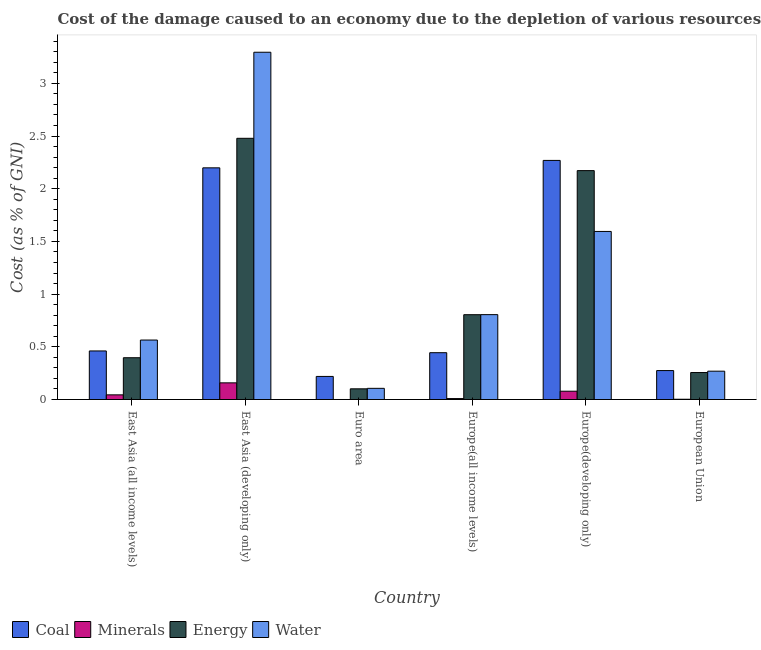How many groups of bars are there?
Offer a very short reply. 6. Are the number of bars per tick equal to the number of legend labels?
Give a very brief answer. Yes. How many bars are there on the 4th tick from the left?
Your answer should be very brief. 4. How many bars are there on the 1st tick from the right?
Give a very brief answer. 4. What is the label of the 1st group of bars from the left?
Give a very brief answer. East Asia (all income levels). In how many cases, is the number of bars for a given country not equal to the number of legend labels?
Provide a succinct answer. 0. What is the cost of damage due to depletion of energy in East Asia (all income levels)?
Keep it short and to the point. 0.4. Across all countries, what is the maximum cost of damage due to depletion of water?
Ensure brevity in your answer.  3.3. Across all countries, what is the minimum cost of damage due to depletion of minerals?
Offer a terse response. 0. In which country was the cost of damage due to depletion of energy maximum?
Your answer should be very brief. East Asia (developing only). What is the total cost of damage due to depletion of water in the graph?
Give a very brief answer. 6.63. What is the difference between the cost of damage due to depletion of water in East Asia (all income levels) and that in European Union?
Provide a short and direct response. 0.3. What is the difference between the cost of damage due to depletion of coal in Euro area and the cost of damage due to depletion of water in European Union?
Your response must be concise. -0.05. What is the average cost of damage due to depletion of energy per country?
Give a very brief answer. 1.03. What is the difference between the cost of damage due to depletion of minerals and cost of damage due to depletion of coal in Euro area?
Keep it short and to the point. -0.22. In how many countries, is the cost of damage due to depletion of energy greater than 2.8 %?
Provide a short and direct response. 0. What is the ratio of the cost of damage due to depletion of coal in East Asia (all income levels) to that in Euro area?
Provide a succinct answer. 2.1. Is the cost of damage due to depletion of water in Europe(all income levels) less than that in Europe(developing only)?
Ensure brevity in your answer.  Yes. Is the difference between the cost of damage due to depletion of water in Europe(all income levels) and Europe(developing only) greater than the difference between the cost of damage due to depletion of minerals in Europe(all income levels) and Europe(developing only)?
Ensure brevity in your answer.  No. What is the difference between the highest and the second highest cost of damage due to depletion of water?
Give a very brief answer. 1.7. What is the difference between the highest and the lowest cost of damage due to depletion of coal?
Make the answer very short. 2.05. Is the sum of the cost of damage due to depletion of minerals in Europe(all income levels) and Europe(developing only) greater than the maximum cost of damage due to depletion of energy across all countries?
Your answer should be compact. No. Is it the case that in every country, the sum of the cost of damage due to depletion of energy and cost of damage due to depletion of coal is greater than the sum of cost of damage due to depletion of minerals and cost of damage due to depletion of water?
Provide a succinct answer. Yes. What does the 1st bar from the left in East Asia (all income levels) represents?
Your answer should be compact. Coal. What does the 2nd bar from the right in East Asia (all income levels) represents?
Provide a succinct answer. Energy. Is it the case that in every country, the sum of the cost of damage due to depletion of coal and cost of damage due to depletion of minerals is greater than the cost of damage due to depletion of energy?
Your answer should be compact. No. Are all the bars in the graph horizontal?
Your response must be concise. No. How many countries are there in the graph?
Ensure brevity in your answer.  6. Does the graph contain any zero values?
Provide a short and direct response. No. Where does the legend appear in the graph?
Your answer should be very brief. Bottom left. What is the title of the graph?
Ensure brevity in your answer.  Cost of the damage caused to an economy due to the depletion of various resources in 1993 . What is the label or title of the X-axis?
Make the answer very short. Country. What is the label or title of the Y-axis?
Provide a succinct answer. Cost (as % of GNI). What is the Cost (as % of GNI) in Coal in East Asia (all income levels)?
Make the answer very short. 0.46. What is the Cost (as % of GNI) of Minerals in East Asia (all income levels)?
Offer a terse response. 0.04. What is the Cost (as % of GNI) in Energy in East Asia (all income levels)?
Your answer should be compact. 0.4. What is the Cost (as % of GNI) in Water in East Asia (all income levels)?
Make the answer very short. 0.56. What is the Cost (as % of GNI) of Coal in East Asia (developing only)?
Your answer should be compact. 2.2. What is the Cost (as % of GNI) in Minerals in East Asia (developing only)?
Make the answer very short. 0.16. What is the Cost (as % of GNI) in Energy in East Asia (developing only)?
Provide a succinct answer. 2.48. What is the Cost (as % of GNI) in Water in East Asia (developing only)?
Your answer should be very brief. 3.3. What is the Cost (as % of GNI) in Coal in Euro area?
Your response must be concise. 0.22. What is the Cost (as % of GNI) in Minerals in Euro area?
Provide a short and direct response. 0. What is the Cost (as % of GNI) of Energy in Euro area?
Provide a short and direct response. 0.1. What is the Cost (as % of GNI) of Water in Euro area?
Your answer should be very brief. 0.11. What is the Cost (as % of GNI) in Coal in Europe(all income levels)?
Your answer should be compact. 0.44. What is the Cost (as % of GNI) of Minerals in Europe(all income levels)?
Provide a succinct answer. 0.01. What is the Cost (as % of GNI) in Energy in Europe(all income levels)?
Your answer should be compact. 0.8. What is the Cost (as % of GNI) of Water in Europe(all income levels)?
Provide a short and direct response. 0.81. What is the Cost (as % of GNI) in Coal in Europe(developing only)?
Provide a succinct answer. 2.27. What is the Cost (as % of GNI) in Minerals in Europe(developing only)?
Ensure brevity in your answer.  0.08. What is the Cost (as % of GNI) of Energy in Europe(developing only)?
Make the answer very short. 2.17. What is the Cost (as % of GNI) in Water in Europe(developing only)?
Ensure brevity in your answer.  1.59. What is the Cost (as % of GNI) of Coal in European Union?
Ensure brevity in your answer.  0.27. What is the Cost (as % of GNI) of Minerals in European Union?
Keep it short and to the point. 0. What is the Cost (as % of GNI) of Energy in European Union?
Give a very brief answer. 0.26. What is the Cost (as % of GNI) in Water in European Union?
Ensure brevity in your answer.  0.27. Across all countries, what is the maximum Cost (as % of GNI) of Coal?
Ensure brevity in your answer.  2.27. Across all countries, what is the maximum Cost (as % of GNI) in Minerals?
Keep it short and to the point. 0.16. Across all countries, what is the maximum Cost (as % of GNI) of Energy?
Keep it short and to the point. 2.48. Across all countries, what is the maximum Cost (as % of GNI) of Water?
Offer a terse response. 3.3. Across all countries, what is the minimum Cost (as % of GNI) of Coal?
Provide a short and direct response. 0.22. Across all countries, what is the minimum Cost (as % of GNI) of Minerals?
Give a very brief answer. 0. Across all countries, what is the minimum Cost (as % of GNI) of Energy?
Offer a very short reply. 0.1. Across all countries, what is the minimum Cost (as % of GNI) of Water?
Provide a short and direct response. 0.11. What is the total Cost (as % of GNI) of Coal in the graph?
Give a very brief answer. 5.87. What is the total Cost (as % of GNI) of Minerals in the graph?
Provide a short and direct response. 0.29. What is the total Cost (as % of GNI) of Energy in the graph?
Your answer should be very brief. 6.21. What is the total Cost (as % of GNI) in Water in the graph?
Keep it short and to the point. 6.63. What is the difference between the Cost (as % of GNI) in Coal in East Asia (all income levels) and that in East Asia (developing only)?
Offer a terse response. -1.74. What is the difference between the Cost (as % of GNI) in Minerals in East Asia (all income levels) and that in East Asia (developing only)?
Your answer should be very brief. -0.11. What is the difference between the Cost (as % of GNI) of Energy in East Asia (all income levels) and that in East Asia (developing only)?
Make the answer very short. -2.08. What is the difference between the Cost (as % of GNI) of Water in East Asia (all income levels) and that in East Asia (developing only)?
Your answer should be compact. -2.73. What is the difference between the Cost (as % of GNI) of Coal in East Asia (all income levels) and that in Euro area?
Keep it short and to the point. 0.24. What is the difference between the Cost (as % of GNI) of Minerals in East Asia (all income levels) and that in Euro area?
Offer a very short reply. 0.04. What is the difference between the Cost (as % of GNI) of Energy in East Asia (all income levels) and that in Euro area?
Your answer should be very brief. 0.29. What is the difference between the Cost (as % of GNI) of Water in East Asia (all income levels) and that in Euro area?
Your answer should be compact. 0.46. What is the difference between the Cost (as % of GNI) of Coal in East Asia (all income levels) and that in Europe(all income levels)?
Your response must be concise. 0.02. What is the difference between the Cost (as % of GNI) of Minerals in East Asia (all income levels) and that in Europe(all income levels)?
Ensure brevity in your answer.  0.04. What is the difference between the Cost (as % of GNI) of Energy in East Asia (all income levels) and that in Europe(all income levels)?
Offer a very short reply. -0.41. What is the difference between the Cost (as % of GNI) in Water in East Asia (all income levels) and that in Europe(all income levels)?
Offer a very short reply. -0.24. What is the difference between the Cost (as % of GNI) of Coal in East Asia (all income levels) and that in Europe(developing only)?
Give a very brief answer. -1.81. What is the difference between the Cost (as % of GNI) in Minerals in East Asia (all income levels) and that in Europe(developing only)?
Keep it short and to the point. -0.03. What is the difference between the Cost (as % of GNI) of Energy in East Asia (all income levels) and that in Europe(developing only)?
Provide a short and direct response. -1.78. What is the difference between the Cost (as % of GNI) of Water in East Asia (all income levels) and that in Europe(developing only)?
Ensure brevity in your answer.  -1.03. What is the difference between the Cost (as % of GNI) of Coal in East Asia (all income levels) and that in European Union?
Make the answer very short. 0.19. What is the difference between the Cost (as % of GNI) of Minerals in East Asia (all income levels) and that in European Union?
Offer a terse response. 0.04. What is the difference between the Cost (as % of GNI) in Energy in East Asia (all income levels) and that in European Union?
Provide a short and direct response. 0.14. What is the difference between the Cost (as % of GNI) of Water in East Asia (all income levels) and that in European Union?
Offer a very short reply. 0.3. What is the difference between the Cost (as % of GNI) in Coal in East Asia (developing only) and that in Euro area?
Your answer should be very brief. 1.98. What is the difference between the Cost (as % of GNI) in Minerals in East Asia (developing only) and that in Euro area?
Offer a terse response. 0.16. What is the difference between the Cost (as % of GNI) of Energy in East Asia (developing only) and that in Euro area?
Your answer should be compact. 2.38. What is the difference between the Cost (as % of GNI) of Water in East Asia (developing only) and that in Euro area?
Your answer should be very brief. 3.19. What is the difference between the Cost (as % of GNI) in Coal in East Asia (developing only) and that in Europe(all income levels)?
Offer a very short reply. 1.75. What is the difference between the Cost (as % of GNI) of Minerals in East Asia (developing only) and that in Europe(all income levels)?
Ensure brevity in your answer.  0.15. What is the difference between the Cost (as % of GNI) in Energy in East Asia (developing only) and that in Europe(all income levels)?
Give a very brief answer. 1.67. What is the difference between the Cost (as % of GNI) in Water in East Asia (developing only) and that in Europe(all income levels)?
Offer a very short reply. 2.49. What is the difference between the Cost (as % of GNI) of Coal in East Asia (developing only) and that in Europe(developing only)?
Make the answer very short. -0.07. What is the difference between the Cost (as % of GNI) of Minerals in East Asia (developing only) and that in Europe(developing only)?
Provide a succinct answer. 0.08. What is the difference between the Cost (as % of GNI) in Energy in East Asia (developing only) and that in Europe(developing only)?
Your response must be concise. 0.31. What is the difference between the Cost (as % of GNI) of Water in East Asia (developing only) and that in Europe(developing only)?
Your answer should be very brief. 1.7. What is the difference between the Cost (as % of GNI) in Coal in East Asia (developing only) and that in European Union?
Make the answer very short. 1.92. What is the difference between the Cost (as % of GNI) in Minerals in East Asia (developing only) and that in European Union?
Make the answer very short. 0.16. What is the difference between the Cost (as % of GNI) of Energy in East Asia (developing only) and that in European Union?
Keep it short and to the point. 2.22. What is the difference between the Cost (as % of GNI) in Water in East Asia (developing only) and that in European Union?
Ensure brevity in your answer.  3.03. What is the difference between the Cost (as % of GNI) in Coal in Euro area and that in Europe(all income levels)?
Make the answer very short. -0.23. What is the difference between the Cost (as % of GNI) in Minerals in Euro area and that in Europe(all income levels)?
Your answer should be compact. -0.01. What is the difference between the Cost (as % of GNI) in Energy in Euro area and that in Europe(all income levels)?
Provide a succinct answer. -0.7. What is the difference between the Cost (as % of GNI) in Water in Euro area and that in Europe(all income levels)?
Your answer should be very brief. -0.7. What is the difference between the Cost (as % of GNI) in Coal in Euro area and that in Europe(developing only)?
Keep it short and to the point. -2.05. What is the difference between the Cost (as % of GNI) in Minerals in Euro area and that in Europe(developing only)?
Your response must be concise. -0.08. What is the difference between the Cost (as % of GNI) in Energy in Euro area and that in Europe(developing only)?
Offer a very short reply. -2.07. What is the difference between the Cost (as % of GNI) in Water in Euro area and that in Europe(developing only)?
Make the answer very short. -1.49. What is the difference between the Cost (as % of GNI) of Coal in Euro area and that in European Union?
Make the answer very short. -0.06. What is the difference between the Cost (as % of GNI) in Minerals in Euro area and that in European Union?
Keep it short and to the point. -0. What is the difference between the Cost (as % of GNI) in Energy in Euro area and that in European Union?
Offer a very short reply. -0.15. What is the difference between the Cost (as % of GNI) in Water in Euro area and that in European Union?
Offer a very short reply. -0.16. What is the difference between the Cost (as % of GNI) in Coal in Europe(all income levels) and that in Europe(developing only)?
Provide a succinct answer. -1.82. What is the difference between the Cost (as % of GNI) in Minerals in Europe(all income levels) and that in Europe(developing only)?
Your response must be concise. -0.07. What is the difference between the Cost (as % of GNI) of Energy in Europe(all income levels) and that in Europe(developing only)?
Your answer should be compact. -1.37. What is the difference between the Cost (as % of GNI) in Water in Europe(all income levels) and that in Europe(developing only)?
Provide a short and direct response. -0.79. What is the difference between the Cost (as % of GNI) of Coal in Europe(all income levels) and that in European Union?
Your answer should be very brief. 0.17. What is the difference between the Cost (as % of GNI) in Minerals in Europe(all income levels) and that in European Union?
Ensure brevity in your answer.  0.01. What is the difference between the Cost (as % of GNI) of Energy in Europe(all income levels) and that in European Union?
Ensure brevity in your answer.  0.55. What is the difference between the Cost (as % of GNI) of Water in Europe(all income levels) and that in European Union?
Provide a short and direct response. 0.54. What is the difference between the Cost (as % of GNI) of Coal in Europe(developing only) and that in European Union?
Your answer should be very brief. 1.99. What is the difference between the Cost (as % of GNI) of Minerals in Europe(developing only) and that in European Union?
Your response must be concise. 0.08. What is the difference between the Cost (as % of GNI) in Energy in Europe(developing only) and that in European Union?
Provide a succinct answer. 1.92. What is the difference between the Cost (as % of GNI) of Water in Europe(developing only) and that in European Union?
Provide a succinct answer. 1.33. What is the difference between the Cost (as % of GNI) of Coal in East Asia (all income levels) and the Cost (as % of GNI) of Minerals in East Asia (developing only)?
Give a very brief answer. 0.3. What is the difference between the Cost (as % of GNI) of Coal in East Asia (all income levels) and the Cost (as % of GNI) of Energy in East Asia (developing only)?
Offer a terse response. -2.02. What is the difference between the Cost (as % of GNI) in Coal in East Asia (all income levels) and the Cost (as % of GNI) in Water in East Asia (developing only)?
Your answer should be compact. -2.83. What is the difference between the Cost (as % of GNI) in Minerals in East Asia (all income levels) and the Cost (as % of GNI) in Energy in East Asia (developing only)?
Keep it short and to the point. -2.43. What is the difference between the Cost (as % of GNI) of Minerals in East Asia (all income levels) and the Cost (as % of GNI) of Water in East Asia (developing only)?
Make the answer very short. -3.25. What is the difference between the Cost (as % of GNI) in Energy in East Asia (all income levels) and the Cost (as % of GNI) in Water in East Asia (developing only)?
Your response must be concise. -2.9. What is the difference between the Cost (as % of GNI) of Coal in East Asia (all income levels) and the Cost (as % of GNI) of Minerals in Euro area?
Provide a short and direct response. 0.46. What is the difference between the Cost (as % of GNI) in Coal in East Asia (all income levels) and the Cost (as % of GNI) in Energy in Euro area?
Offer a very short reply. 0.36. What is the difference between the Cost (as % of GNI) in Coal in East Asia (all income levels) and the Cost (as % of GNI) in Water in Euro area?
Offer a terse response. 0.35. What is the difference between the Cost (as % of GNI) in Minerals in East Asia (all income levels) and the Cost (as % of GNI) in Energy in Euro area?
Keep it short and to the point. -0.06. What is the difference between the Cost (as % of GNI) of Minerals in East Asia (all income levels) and the Cost (as % of GNI) of Water in Euro area?
Your answer should be very brief. -0.06. What is the difference between the Cost (as % of GNI) of Energy in East Asia (all income levels) and the Cost (as % of GNI) of Water in Euro area?
Give a very brief answer. 0.29. What is the difference between the Cost (as % of GNI) of Coal in East Asia (all income levels) and the Cost (as % of GNI) of Minerals in Europe(all income levels)?
Keep it short and to the point. 0.45. What is the difference between the Cost (as % of GNI) in Coal in East Asia (all income levels) and the Cost (as % of GNI) in Energy in Europe(all income levels)?
Keep it short and to the point. -0.34. What is the difference between the Cost (as % of GNI) of Coal in East Asia (all income levels) and the Cost (as % of GNI) of Water in Europe(all income levels)?
Your answer should be very brief. -0.34. What is the difference between the Cost (as % of GNI) in Minerals in East Asia (all income levels) and the Cost (as % of GNI) in Energy in Europe(all income levels)?
Provide a succinct answer. -0.76. What is the difference between the Cost (as % of GNI) in Minerals in East Asia (all income levels) and the Cost (as % of GNI) in Water in Europe(all income levels)?
Give a very brief answer. -0.76. What is the difference between the Cost (as % of GNI) in Energy in East Asia (all income levels) and the Cost (as % of GNI) in Water in Europe(all income levels)?
Ensure brevity in your answer.  -0.41. What is the difference between the Cost (as % of GNI) of Coal in East Asia (all income levels) and the Cost (as % of GNI) of Minerals in Europe(developing only)?
Provide a succinct answer. 0.38. What is the difference between the Cost (as % of GNI) of Coal in East Asia (all income levels) and the Cost (as % of GNI) of Energy in Europe(developing only)?
Your answer should be compact. -1.71. What is the difference between the Cost (as % of GNI) in Coal in East Asia (all income levels) and the Cost (as % of GNI) in Water in Europe(developing only)?
Make the answer very short. -1.13. What is the difference between the Cost (as % of GNI) of Minerals in East Asia (all income levels) and the Cost (as % of GNI) of Energy in Europe(developing only)?
Offer a very short reply. -2.13. What is the difference between the Cost (as % of GNI) of Minerals in East Asia (all income levels) and the Cost (as % of GNI) of Water in Europe(developing only)?
Your answer should be very brief. -1.55. What is the difference between the Cost (as % of GNI) of Energy in East Asia (all income levels) and the Cost (as % of GNI) of Water in Europe(developing only)?
Your answer should be very brief. -1.2. What is the difference between the Cost (as % of GNI) in Coal in East Asia (all income levels) and the Cost (as % of GNI) in Minerals in European Union?
Your answer should be very brief. 0.46. What is the difference between the Cost (as % of GNI) in Coal in East Asia (all income levels) and the Cost (as % of GNI) in Energy in European Union?
Your answer should be compact. 0.2. What is the difference between the Cost (as % of GNI) of Coal in East Asia (all income levels) and the Cost (as % of GNI) of Water in European Union?
Your response must be concise. 0.19. What is the difference between the Cost (as % of GNI) in Minerals in East Asia (all income levels) and the Cost (as % of GNI) in Energy in European Union?
Keep it short and to the point. -0.21. What is the difference between the Cost (as % of GNI) in Minerals in East Asia (all income levels) and the Cost (as % of GNI) in Water in European Union?
Offer a very short reply. -0.22. What is the difference between the Cost (as % of GNI) of Energy in East Asia (all income levels) and the Cost (as % of GNI) of Water in European Union?
Your answer should be compact. 0.13. What is the difference between the Cost (as % of GNI) of Coal in East Asia (developing only) and the Cost (as % of GNI) of Minerals in Euro area?
Your answer should be very brief. 2.2. What is the difference between the Cost (as % of GNI) of Coal in East Asia (developing only) and the Cost (as % of GNI) of Energy in Euro area?
Provide a succinct answer. 2.1. What is the difference between the Cost (as % of GNI) of Coal in East Asia (developing only) and the Cost (as % of GNI) of Water in Euro area?
Keep it short and to the point. 2.09. What is the difference between the Cost (as % of GNI) in Minerals in East Asia (developing only) and the Cost (as % of GNI) in Energy in Euro area?
Your answer should be compact. 0.06. What is the difference between the Cost (as % of GNI) of Minerals in East Asia (developing only) and the Cost (as % of GNI) of Water in Euro area?
Ensure brevity in your answer.  0.05. What is the difference between the Cost (as % of GNI) of Energy in East Asia (developing only) and the Cost (as % of GNI) of Water in Euro area?
Keep it short and to the point. 2.37. What is the difference between the Cost (as % of GNI) in Coal in East Asia (developing only) and the Cost (as % of GNI) in Minerals in Europe(all income levels)?
Give a very brief answer. 2.19. What is the difference between the Cost (as % of GNI) of Coal in East Asia (developing only) and the Cost (as % of GNI) of Energy in Europe(all income levels)?
Offer a very short reply. 1.39. What is the difference between the Cost (as % of GNI) of Coal in East Asia (developing only) and the Cost (as % of GNI) of Water in Europe(all income levels)?
Keep it short and to the point. 1.39. What is the difference between the Cost (as % of GNI) in Minerals in East Asia (developing only) and the Cost (as % of GNI) in Energy in Europe(all income levels)?
Make the answer very short. -0.65. What is the difference between the Cost (as % of GNI) of Minerals in East Asia (developing only) and the Cost (as % of GNI) of Water in Europe(all income levels)?
Offer a very short reply. -0.65. What is the difference between the Cost (as % of GNI) in Energy in East Asia (developing only) and the Cost (as % of GNI) in Water in Europe(all income levels)?
Provide a succinct answer. 1.67. What is the difference between the Cost (as % of GNI) in Coal in East Asia (developing only) and the Cost (as % of GNI) in Minerals in Europe(developing only)?
Offer a terse response. 2.12. What is the difference between the Cost (as % of GNI) in Coal in East Asia (developing only) and the Cost (as % of GNI) in Energy in Europe(developing only)?
Make the answer very short. 0.03. What is the difference between the Cost (as % of GNI) in Coal in East Asia (developing only) and the Cost (as % of GNI) in Water in Europe(developing only)?
Make the answer very short. 0.6. What is the difference between the Cost (as % of GNI) of Minerals in East Asia (developing only) and the Cost (as % of GNI) of Energy in Europe(developing only)?
Your answer should be compact. -2.01. What is the difference between the Cost (as % of GNI) in Minerals in East Asia (developing only) and the Cost (as % of GNI) in Water in Europe(developing only)?
Make the answer very short. -1.44. What is the difference between the Cost (as % of GNI) in Energy in East Asia (developing only) and the Cost (as % of GNI) in Water in Europe(developing only)?
Your answer should be compact. 0.88. What is the difference between the Cost (as % of GNI) in Coal in East Asia (developing only) and the Cost (as % of GNI) in Minerals in European Union?
Give a very brief answer. 2.2. What is the difference between the Cost (as % of GNI) of Coal in East Asia (developing only) and the Cost (as % of GNI) of Energy in European Union?
Make the answer very short. 1.94. What is the difference between the Cost (as % of GNI) of Coal in East Asia (developing only) and the Cost (as % of GNI) of Water in European Union?
Ensure brevity in your answer.  1.93. What is the difference between the Cost (as % of GNI) of Minerals in East Asia (developing only) and the Cost (as % of GNI) of Energy in European Union?
Offer a terse response. -0.1. What is the difference between the Cost (as % of GNI) in Minerals in East Asia (developing only) and the Cost (as % of GNI) in Water in European Union?
Keep it short and to the point. -0.11. What is the difference between the Cost (as % of GNI) in Energy in East Asia (developing only) and the Cost (as % of GNI) in Water in European Union?
Offer a terse response. 2.21. What is the difference between the Cost (as % of GNI) of Coal in Euro area and the Cost (as % of GNI) of Minerals in Europe(all income levels)?
Your answer should be very brief. 0.21. What is the difference between the Cost (as % of GNI) of Coal in Euro area and the Cost (as % of GNI) of Energy in Europe(all income levels)?
Your response must be concise. -0.59. What is the difference between the Cost (as % of GNI) of Coal in Euro area and the Cost (as % of GNI) of Water in Europe(all income levels)?
Make the answer very short. -0.59. What is the difference between the Cost (as % of GNI) of Minerals in Euro area and the Cost (as % of GNI) of Energy in Europe(all income levels)?
Offer a terse response. -0.8. What is the difference between the Cost (as % of GNI) of Minerals in Euro area and the Cost (as % of GNI) of Water in Europe(all income levels)?
Your answer should be compact. -0.81. What is the difference between the Cost (as % of GNI) of Energy in Euro area and the Cost (as % of GNI) of Water in Europe(all income levels)?
Your answer should be compact. -0.7. What is the difference between the Cost (as % of GNI) of Coal in Euro area and the Cost (as % of GNI) of Minerals in Europe(developing only)?
Offer a terse response. 0.14. What is the difference between the Cost (as % of GNI) of Coal in Euro area and the Cost (as % of GNI) of Energy in Europe(developing only)?
Provide a short and direct response. -1.95. What is the difference between the Cost (as % of GNI) in Coal in Euro area and the Cost (as % of GNI) in Water in Europe(developing only)?
Offer a very short reply. -1.38. What is the difference between the Cost (as % of GNI) in Minerals in Euro area and the Cost (as % of GNI) in Energy in Europe(developing only)?
Ensure brevity in your answer.  -2.17. What is the difference between the Cost (as % of GNI) of Minerals in Euro area and the Cost (as % of GNI) of Water in Europe(developing only)?
Your answer should be compact. -1.59. What is the difference between the Cost (as % of GNI) in Energy in Euro area and the Cost (as % of GNI) in Water in Europe(developing only)?
Your response must be concise. -1.49. What is the difference between the Cost (as % of GNI) in Coal in Euro area and the Cost (as % of GNI) in Minerals in European Union?
Provide a short and direct response. 0.22. What is the difference between the Cost (as % of GNI) of Coal in Euro area and the Cost (as % of GNI) of Energy in European Union?
Provide a short and direct response. -0.04. What is the difference between the Cost (as % of GNI) of Coal in Euro area and the Cost (as % of GNI) of Water in European Union?
Provide a succinct answer. -0.05. What is the difference between the Cost (as % of GNI) of Minerals in Euro area and the Cost (as % of GNI) of Energy in European Union?
Make the answer very short. -0.26. What is the difference between the Cost (as % of GNI) in Minerals in Euro area and the Cost (as % of GNI) in Water in European Union?
Your answer should be compact. -0.27. What is the difference between the Cost (as % of GNI) of Energy in Euro area and the Cost (as % of GNI) of Water in European Union?
Keep it short and to the point. -0.17. What is the difference between the Cost (as % of GNI) in Coal in Europe(all income levels) and the Cost (as % of GNI) in Minerals in Europe(developing only)?
Make the answer very short. 0.37. What is the difference between the Cost (as % of GNI) of Coal in Europe(all income levels) and the Cost (as % of GNI) of Energy in Europe(developing only)?
Provide a short and direct response. -1.73. What is the difference between the Cost (as % of GNI) of Coal in Europe(all income levels) and the Cost (as % of GNI) of Water in Europe(developing only)?
Offer a very short reply. -1.15. What is the difference between the Cost (as % of GNI) in Minerals in Europe(all income levels) and the Cost (as % of GNI) in Energy in Europe(developing only)?
Give a very brief answer. -2.16. What is the difference between the Cost (as % of GNI) of Minerals in Europe(all income levels) and the Cost (as % of GNI) of Water in Europe(developing only)?
Provide a short and direct response. -1.59. What is the difference between the Cost (as % of GNI) of Energy in Europe(all income levels) and the Cost (as % of GNI) of Water in Europe(developing only)?
Your answer should be compact. -0.79. What is the difference between the Cost (as % of GNI) in Coal in Europe(all income levels) and the Cost (as % of GNI) in Minerals in European Union?
Provide a succinct answer. 0.44. What is the difference between the Cost (as % of GNI) in Coal in Europe(all income levels) and the Cost (as % of GNI) in Energy in European Union?
Provide a succinct answer. 0.19. What is the difference between the Cost (as % of GNI) of Coal in Europe(all income levels) and the Cost (as % of GNI) of Water in European Union?
Make the answer very short. 0.18. What is the difference between the Cost (as % of GNI) in Minerals in Europe(all income levels) and the Cost (as % of GNI) in Energy in European Union?
Make the answer very short. -0.25. What is the difference between the Cost (as % of GNI) in Minerals in Europe(all income levels) and the Cost (as % of GNI) in Water in European Union?
Your answer should be compact. -0.26. What is the difference between the Cost (as % of GNI) of Energy in Europe(all income levels) and the Cost (as % of GNI) of Water in European Union?
Give a very brief answer. 0.54. What is the difference between the Cost (as % of GNI) of Coal in Europe(developing only) and the Cost (as % of GNI) of Minerals in European Union?
Provide a short and direct response. 2.27. What is the difference between the Cost (as % of GNI) in Coal in Europe(developing only) and the Cost (as % of GNI) in Energy in European Union?
Offer a terse response. 2.01. What is the difference between the Cost (as % of GNI) of Coal in Europe(developing only) and the Cost (as % of GNI) of Water in European Union?
Your answer should be very brief. 2. What is the difference between the Cost (as % of GNI) of Minerals in Europe(developing only) and the Cost (as % of GNI) of Energy in European Union?
Provide a short and direct response. -0.18. What is the difference between the Cost (as % of GNI) of Minerals in Europe(developing only) and the Cost (as % of GNI) of Water in European Union?
Give a very brief answer. -0.19. What is the difference between the Cost (as % of GNI) of Energy in Europe(developing only) and the Cost (as % of GNI) of Water in European Union?
Offer a very short reply. 1.9. What is the average Cost (as % of GNI) in Coal per country?
Provide a short and direct response. 0.98. What is the average Cost (as % of GNI) in Minerals per country?
Keep it short and to the point. 0.05. What is the average Cost (as % of GNI) of Energy per country?
Provide a short and direct response. 1.03. What is the average Cost (as % of GNI) of Water per country?
Make the answer very short. 1.11. What is the difference between the Cost (as % of GNI) of Coal and Cost (as % of GNI) of Minerals in East Asia (all income levels)?
Give a very brief answer. 0.42. What is the difference between the Cost (as % of GNI) in Coal and Cost (as % of GNI) in Energy in East Asia (all income levels)?
Provide a short and direct response. 0.06. What is the difference between the Cost (as % of GNI) in Coal and Cost (as % of GNI) in Water in East Asia (all income levels)?
Offer a very short reply. -0.1. What is the difference between the Cost (as % of GNI) in Minerals and Cost (as % of GNI) in Energy in East Asia (all income levels)?
Make the answer very short. -0.35. What is the difference between the Cost (as % of GNI) of Minerals and Cost (as % of GNI) of Water in East Asia (all income levels)?
Your response must be concise. -0.52. What is the difference between the Cost (as % of GNI) of Energy and Cost (as % of GNI) of Water in East Asia (all income levels)?
Offer a terse response. -0.17. What is the difference between the Cost (as % of GNI) of Coal and Cost (as % of GNI) of Minerals in East Asia (developing only)?
Your answer should be very brief. 2.04. What is the difference between the Cost (as % of GNI) in Coal and Cost (as % of GNI) in Energy in East Asia (developing only)?
Your answer should be compact. -0.28. What is the difference between the Cost (as % of GNI) in Coal and Cost (as % of GNI) in Water in East Asia (developing only)?
Ensure brevity in your answer.  -1.1. What is the difference between the Cost (as % of GNI) in Minerals and Cost (as % of GNI) in Energy in East Asia (developing only)?
Make the answer very short. -2.32. What is the difference between the Cost (as % of GNI) of Minerals and Cost (as % of GNI) of Water in East Asia (developing only)?
Keep it short and to the point. -3.14. What is the difference between the Cost (as % of GNI) in Energy and Cost (as % of GNI) in Water in East Asia (developing only)?
Ensure brevity in your answer.  -0.82. What is the difference between the Cost (as % of GNI) of Coal and Cost (as % of GNI) of Minerals in Euro area?
Your response must be concise. 0.22. What is the difference between the Cost (as % of GNI) of Coal and Cost (as % of GNI) of Energy in Euro area?
Provide a short and direct response. 0.12. What is the difference between the Cost (as % of GNI) of Coal and Cost (as % of GNI) of Water in Euro area?
Offer a terse response. 0.11. What is the difference between the Cost (as % of GNI) in Minerals and Cost (as % of GNI) in Energy in Euro area?
Your answer should be compact. -0.1. What is the difference between the Cost (as % of GNI) of Minerals and Cost (as % of GNI) of Water in Euro area?
Provide a succinct answer. -0.11. What is the difference between the Cost (as % of GNI) in Energy and Cost (as % of GNI) in Water in Euro area?
Give a very brief answer. -0. What is the difference between the Cost (as % of GNI) of Coal and Cost (as % of GNI) of Minerals in Europe(all income levels)?
Your answer should be very brief. 0.44. What is the difference between the Cost (as % of GNI) of Coal and Cost (as % of GNI) of Energy in Europe(all income levels)?
Make the answer very short. -0.36. What is the difference between the Cost (as % of GNI) in Coal and Cost (as % of GNI) in Water in Europe(all income levels)?
Offer a terse response. -0.36. What is the difference between the Cost (as % of GNI) of Minerals and Cost (as % of GNI) of Energy in Europe(all income levels)?
Provide a short and direct response. -0.8. What is the difference between the Cost (as % of GNI) of Minerals and Cost (as % of GNI) of Water in Europe(all income levels)?
Give a very brief answer. -0.8. What is the difference between the Cost (as % of GNI) in Energy and Cost (as % of GNI) in Water in Europe(all income levels)?
Offer a very short reply. -0. What is the difference between the Cost (as % of GNI) of Coal and Cost (as % of GNI) of Minerals in Europe(developing only)?
Give a very brief answer. 2.19. What is the difference between the Cost (as % of GNI) of Coal and Cost (as % of GNI) of Energy in Europe(developing only)?
Provide a succinct answer. 0.1. What is the difference between the Cost (as % of GNI) in Coal and Cost (as % of GNI) in Water in Europe(developing only)?
Make the answer very short. 0.67. What is the difference between the Cost (as % of GNI) in Minerals and Cost (as % of GNI) in Energy in Europe(developing only)?
Make the answer very short. -2.09. What is the difference between the Cost (as % of GNI) in Minerals and Cost (as % of GNI) in Water in Europe(developing only)?
Offer a very short reply. -1.52. What is the difference between the Cost (as % of GNI) of Energy and Cost (as % of GNI) of Water in Europe(developing only)?
Your answer should be compact. 0.58. What is the difference between the Cost (as % of GNI) in Coal and Cost (as % of GNI) in Minerals in European Union?
Provide a short and direct response. 0.27. What is the difference between the Cost (as % of GNI) in Coal and Cost (as % of GNI) in Energy in European Union?
Offer a very short reply. 0.02. What is the difference between the Cost (as % of GNI) of Coal and Cost (as % of GNI) of Water in European Union?
Your response must be concise. 0.01. What is the difference between the Cost (as % of GNI) of Minerals and Cost (as % of GNI) of Energy in European Union?
Make the answer very short. -0.25. What is the difference between the Cost (as % of GNI) of Minerals and Cost (as % of GNI) of Water in European Union?
Provide a short and direct response. -0.27. What is the difference between the Cost (as % of GNI) of Energy and Cost (as % of GNI) of Water in European Union?
Provide a short and direct response. -0.01. What is the ratio of the Cost (as % of GNI) in Coal in East Asia (all income levels) to that in East Asia (developing only)?
Your response must be concise. 0.21. What is the ratio of the Cost (as % of GNI) in Minerals in East Asia (all income levels) to that in East Asia (developing only)?
Provide a short and direct response. 0.28. What is the ratio of the Cost (as % of GNI) in Energy in East Asia (all income levels) to that in East Asia (developing only)?
Make the answer very short. 0.16. What is the ratio of the Cost (as % of GNI) in Water in East Asia (all income levels) to that in East Asia (developing only)?
Give a very brief answer. 0.17. What is the ratio of the Cost (as % of GNI) in Coal in East Asia (all income levels) to that in Euro area?
Your answer should be very brief. 2.1. What is the ratio of the Cost (as % of GNI) of Minerals in East Asia (all income levels) to that in Euro area?
Your answer should be very brief. 140.29. What is the ratio of the Cost (as % of GNI) of Energy in East Asia (all income levels) to that in Euro area?
Your response must be concise. 3.9. What is the ratio of the Cost (as % of GNI) of Water in East Asia (all income levels) to that in Euro area?
Your answer should be very brief. 5.32. What is the ratio of the Cost (as % of GNI) of Coal in East Asia (all income levels) to that in Europe(all income levels)?
Your response must be concise. 1.04. What is the ratio of the Cost (as % of GNI) of Minerals in East Asia (all income levels) to that in Europe(all income levels)?
Provide a short and direct response. 4.93. What is the ratio of the Cost (as % of GNI) of Energy in East Asia (all income levels) to that in Europe(all income levels)?
Ensure brevity in your answer.  0.49. What is the ratio of the Cost (as % of GNI) of Water in East Asia (all income levels) to that in Europe(all income levels)?
Ensure brevity in your answer.  0.7. What is the ratio of the Cost (as % of GNI) of Coal in East Asia (all income levels) to that in Europe(developing only)?
Make the answer very short. 0.2. What is the ratio of the Cost (as % of GNI) of Minerals in East Asia (all income levels) to that in Europe(developing only)?
Make the answer very short. 0.56. What is the ratio of the Cost (as % of GNI) in Energy in East Asia (all income levels) to that in Europe(developing only)?
Your answer should be compact. 0.18. What is the ratio of the Cost (as % of GNI) of Water in East Asia (all income levels) to that in Europe(developing only)?
Your answer should be very brief. 0.35. What is the ratio of the Cost (as % of GNI) of Coal in East Asia (all income levels) to that in European Union?
Your response must be concise. 1.68. What is the ratio of the Cost (as % of GNI) in Minerals in East Asia (all income levels) to that in European Union?
Provide a succinct answer. 17.09. What is the ratio of the Cost (as % of GNI) in Energy in East Asia (all income levels) to that in European Union?
Give a very brief answer. 1.55. What is the ratio of the Cost (as % of GNI) of Water in East Asia (all income levels) to that in European Union?
Keep it short and to the point. 2.1. What is the ratio of the Cost (as % of GNI) of Coal in East Asia (developing only) to that in Euro area?
Offer a terse response. 10.03. What is the ratio of the Cost (as % of GNI) in Minerals in East Asia (developing only) to that in Euro area?
Ensure brevity in your answer.  500.38. What is the ratio of the Cost (as % of GNI) of Energy in East Asia (developing only) to that in Euro area?
Offer a terse response. 24.41. What is the ratio of the Cost (as % of GNI) of Water in East Asia (developing only) to that in Euro area?
Your response must be concise. 31.05. What is the ratio of the Cost (as % of GNI) of Coal in East Asia (developing only) to that in Europe(all income levels)?
Provide a short and direct response. 4.95. What is the ratio of the Cost (as % of GNI) in Minerals in East Asia (developing only) to that in Europe(all income levels)?
Your answer should be compact. 17.6. What is the ratio of the Cost (as % of GNI) of Energy in East Asia (developing only) to that in Europe(all income levels)?
Ensure brevity in your answer.  3.08. What is the ratio of the Cost (as % of GNI) of Water in East Asia (developing only) to that in Europe(all income levels)?
Provide a succinct answer. 4.09. What is the ratio of the Cost (as % of GNI) in Minerals in East Asia (developing only) to that in Europe(developing only)?
Make the answer very short. 2.01. What is the ratio of the Cost (as % of GNI) in Energy in East Asia (developing only) to that in Europe(developing only)?
Your answer should be very brief. 1.14. What is the ratio of the Cost (as % of GNI) of Water in East Asia (developing only) to that in Europe(developing only)?
Your answer should be compact. 2.07. What is the ratio of the Cost (as % of GNI) of Coal in East Asia (developing only) to that in European Union?
Offer a very short reply. 8. What is the ratio of the Cost (as % of GNI) of Minerals in East Asia (developing only) to that in European Union?
Offer a terse response. 60.95. What is the ratio of the Cost (as % of GNI) in Energy in East Asia (developing only) to that in European Union?
Your response must be concise. 9.68. What is the ratio of the Cost (as % of GNI) in Water in East Asia (developing only) to that in European Union?
Make the answer very short. 12.25. What is the ratio of the Cost (as % of GNI) in Coal in Euro area to that in Europe(all income levels)?
Give a very brief answer. 0.49. What is the ratio of the Cost (as % of GNI) in Minerals in Euro area to that in Europe(all income levels)?
Your answer should be compact. 0.04. What is the ratio of the Cost (as % of GNI) in Energy in Euro area to that in Europe(all income levels)?
Keep it short and to the point. 0.13. What is the ratio of the Cost (as % of GNI) in Water in Euro area to that in Europe(all income levels)?
Offer a terse response. 0.13. What is the ratio of the Cost (as % of GNI) in Coal in Euro area to that in Europe(developing only)?
Make the answer very short. 0.1. What is the ratio of the Cost (as % of GNI) in Minerals in Euro area to that in Europe(developing only)?
Provide a succinct answer. 0. What is the ratio of the Cost (as % of GNI) of Energy in Euro area to that in Europe(developing only)?
Make the answer very short. 0.05. What is the ratio of the Cost (as % of GNI) of Water in Euro area to that in Europe(developing only)?
Ensure brevity in your answer.  0.07. What is the ratio of the Cost (as % of GNI) of Coal in Euro area to that in European Union?
Provide a short and direct response. 0.8. What is the ratio of the Cost (as % of GNI) in Minerals in Euro area to that in European Union?
Your answer should be very brief. 0.12. What is the ratio of the Cost (as % of GNI) of Energy in Euro area to that in European Union?
Keep it short and to the point. 0.4. What is the ratio of the Cost (as % of GNI) in Water in Euro area to that in European Union?
Provide a succinct answer. 0.39. What is the ratio of the Cost (as % of GNI) of Coal in Europe(all income levels) to that in Europe(developing only)?
Offer a terse response. 0.2. What is the ratio of the Cost (as % of GNI) of Minerals in Europe(all income levels) to that in Europe(developing only)?
Make the answer very short. 0.11. What is the ratio of the Cost (as % of GNI) in Energy in Europe(all income levels) to that in Europe(developing only)?
Your answer should be very brief. 0.37. What is the ratio of the Cost (as % of GNI) of Water in Europe(all income levels) to that in Europe(developing only)?
Your answer should be compact. 0.51. What is the ratio of the Cost (as % of GNI) in Coal in Europe(all income levels) to that in European Union?
Your answer should be compact. 1.62. What is the ratio of the Cost (as % of GNI) in Minerals in Europe(all income levels) to that in European Union?
Keep it short and to the point. 3.46. What is the ratio of the Cost (as % of GNI) of Energy in Europe(all income levels) to that in European Union?
Your answer should be compact. 3.14. What is the ratio of the Cost (as % of GNI) of Water in Europe(all income levels) to that in European Union?
Make the answer very short. 3. What is the ratio of the Cost (as % of GNI) in Coal in Europe(developing only) to that in European Union?
Ensure brevity in your answer.  8.26. What is the ratio of the Cost (as % of GNI) in Minerals in Europe(developing only) to that in European Union?
Make the answer very short. 30.36. What is the ratio of the Cost (as % of GNI) of Energy in Europe(developing only) to that in European Union?
Provide a short and direct response. 8.49. What is the ratio of the Cost (as % of GNI) of Water in Europe(developing only) to that in European Union?
Your response must be concise. 5.93. What is the difference between the highest and the second highest Cost (as % of GNI) in Coal?
Offer a very short reply. 0.07. What is the difference between the highest and the second highest Cost (as % of GNI) of Minerals?
Offer a terse response. 0.08. What is the difference between the highest and the second highest Cost (as % of GNI) of Energy?
Provide a succinct answer. 0.31. What is the difference between the highest and the second highest Cost (as % of GNI) of Water?
Keep it short and to the point. 1.7. What is the difference between the highest and the lowest Cost (as % of GNI) of Coal?
Your answer should be very brief. 2.05. What is the difference between the highest and the lowest Cost (as % of GNI) in Minerals?
Offer a terse response. 0.16. What is the difference between the highest and the lowest Cost (as % of GNI) in Energy?
Make the answer very short. 2.38. What is the difference between the highest and the lowest Cost (as % of GNI) of Water?
Keep it short and to the point. 3.19. 